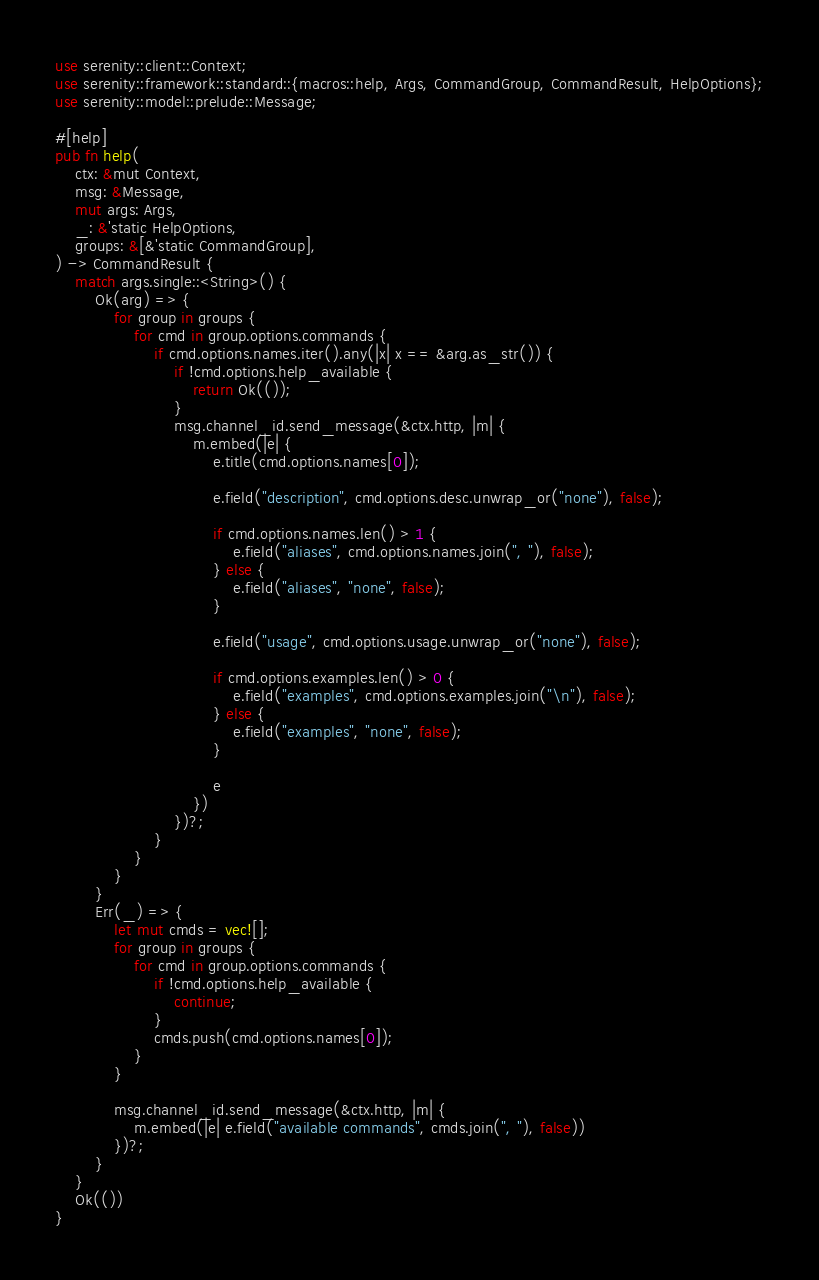<code> <loc_0><loc_0><loc_500><loc_500><_Rust_>use serenity::client::Context;
use serenity::framework::standard::{macros::help, Args, CommandGroup, CommandResult, HelpOptions};
use serenity::model::prelude::Message;

#[help]
pub fn help(
    ctx: &mut Context,
    msg: &Message,
    mut args: Args,
    _: &'static HelpOptions,
    groups: &[&'static CommandGroup],
) -> CommandResult {
    match args.single::<String>() {
        Ok(arg) => {
            for group in groups {
                for cmd in group.options.commands {
                    if cmd.options.names.iter().any(|x| x == &arg.as_str()) {
                        if !cmd.options.help_available {
                            return Ok(());
                        }
                        msg.channel_id.send_message(&ctx.http, |m| {
                            m.embed(|e| {
                                e.title(cmd.options.names[0]);

                                e.field("description", cmd.options.desc.unwrap_or("none"), false);

                                if cmd.options.names.len() > 1 {
                                    e.field("aliases", cmd.options.names.join(", "), false);
                                } else {
                                    e.field("aliases", "none", false);
                                }

                                e.field("usage", cmd.options.usage.unwrap_or("none"), false);

                                if cmd.options.examples.len() > 0 {
                                    e.field("examples", cmd.options.examples.join("\n"), false);
                                } else {
                                    e.field("examples", "none", false);
                                }

                                e
                            })
                        })?;
                    }
                }
            }
        }
        Err(_) => {
            let mut cmds = vec![];
            for group in groups {
                for cmd in group.options.commands {
                    if !cmd.options.help_available {
                        continue;
                    }
                    cmds.push(cmd.options.names[0]);
                }
            }

            msg.channel_id.send_message(&ctx.http, |m| {
                m.embed(|e| e.field("available commands", cmds.join(", "), false))
            })?;
        }
    }
    Ok(())
}
</code> 